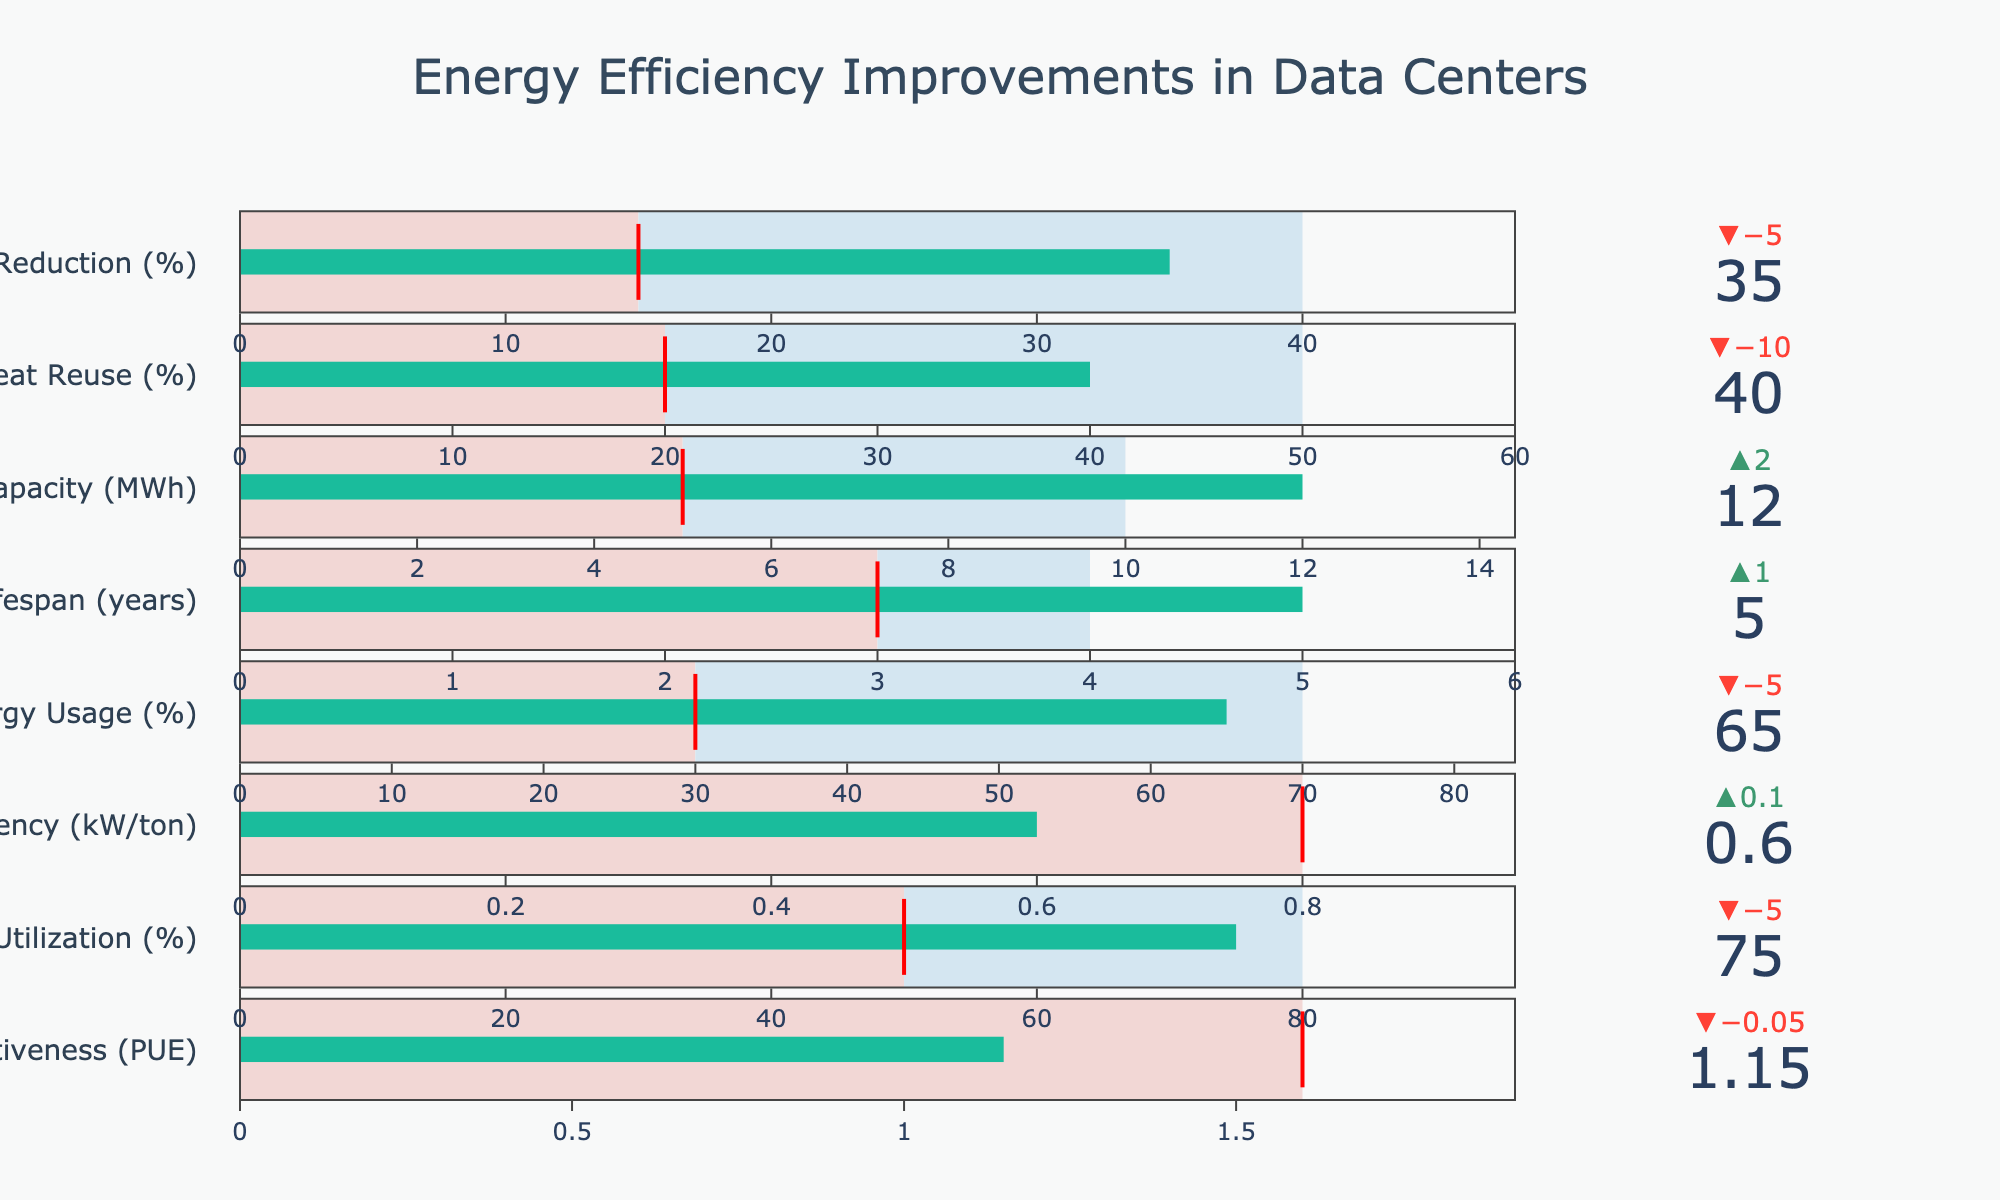How many categories are displayed in the bullet chart? There are 8 categories displayed in the chart: Power Usage Effectiveness (PUE), Server Utilization (%), Cooling Efficiency (kW/ton), Renewable Energy Usage (%), IT Equipment Lifespan (years), Energy Storage Capacity (MWh), Heat Reuse (%), and Idle Server Power Reduction (%).
Answer: 8 What is the industry standard for Cooling Efficiency (kW/ton)? The industry standard for Cooling Efficiency (kW/ton) is given directly in the chart and it is marked by a red line in the bullet chart corresponding to the Cooling Efficiency category.
Answer: 0.8 Which category has the largest difference between the actual and the industry standard values? To determine this, we need to calculate the difference between the actual and the industry standard values for each category: PUE (1.15 - 1.6), Server Utilization (75% - 50%), Cooling Efficiency (0.6 - 0.8), Renewable Energy Usage (65% - 30%), IT Equipment Lifespan (5 - 3), Energy Storage Capacity (12 - 5), Heat Reuse (40% - 20%), Idle Server Power Reduction (35% - 15%). The largest difference is for Renewable Energy Usage (65% - 30% = 35%).
Answer: Renewable Energy Usage (%) Which category has the actual value exceeding the target value? Looking at the bullet chart, we compare the actual values and target values across all categories. The category where the actual value exceeds the target value is IT Equipment Lifespan (actual = 5 years, target = 4 years).
Answer: IT Equipment Lifespan (years) What is the target value for Server Utilization (%)? The target value for Server Utilization (%) is indicated in the bullet chart and is directly mentioned in the data.
Answer: 80% How much does the actual Power Usage Effectiveness (PUE) differ from the target? To find the difference, subtract the target value from the actual value for PUE: (1.15 - 1.2 = -0.05). This means the actual PUE is 0.05 units less than the target.
Answer: -0.05 Compare the effectiveness in terms of Power Usage Effectiveness (PUE) between the data center and the industry standard. The actual PUE value of the data center is 1.15, while the industry standard is 1.6. The data center's PUE is lower than the industry standard by 0.45 units, which indicates better efficiency.
Answer: 0.45 units better What percentage of the industry's standard Heat Reuse (%) has the data center achieved? To determine this, divide the actual Heat Reuse (%) by the industry standard, then multiply by 100 to get the percentage: (40 / 20) * 100 = 200%. This means the data center has achieved 200% of the industry's standard in Heat Reuse.
Answer: 200% How does the data center's Idle Server Power Reduction (%) compare to the industry standard? The actual value for Idle Server Power Reduction is 35%, and the industry standard is 15%. The data center's reduction is 20% higher than the industry standard.
Answer: 20% higher 